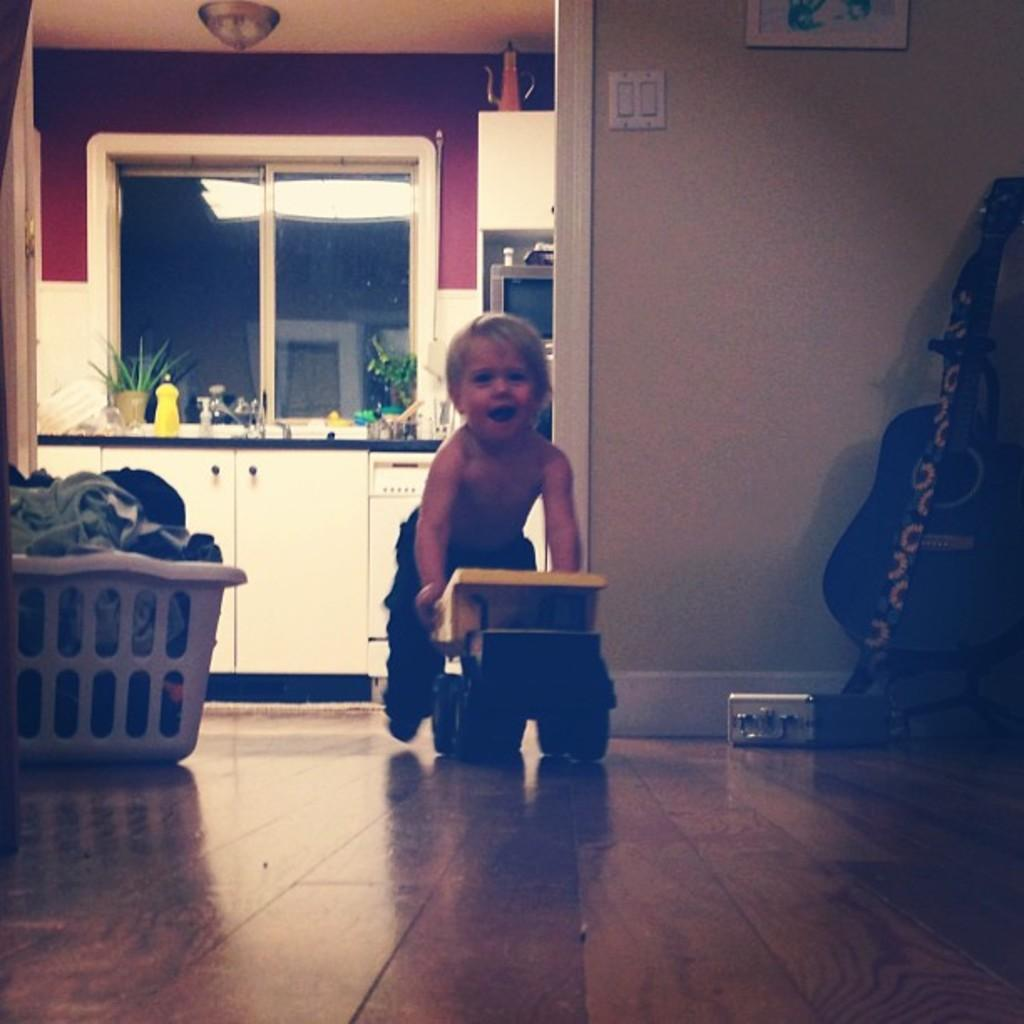What is the kid doing in the image? The kid is playing with a toy in the image. What object can be seen on the floor? There is a basket on the floor in the image. What musical instrument is present in the image? There is a guitar in the image. What can be seen in the background of the image? There is a wall visible in the image. What type of bun is the kid holding in the image? There is no bun present in the image; the kid is playing with a toy. 